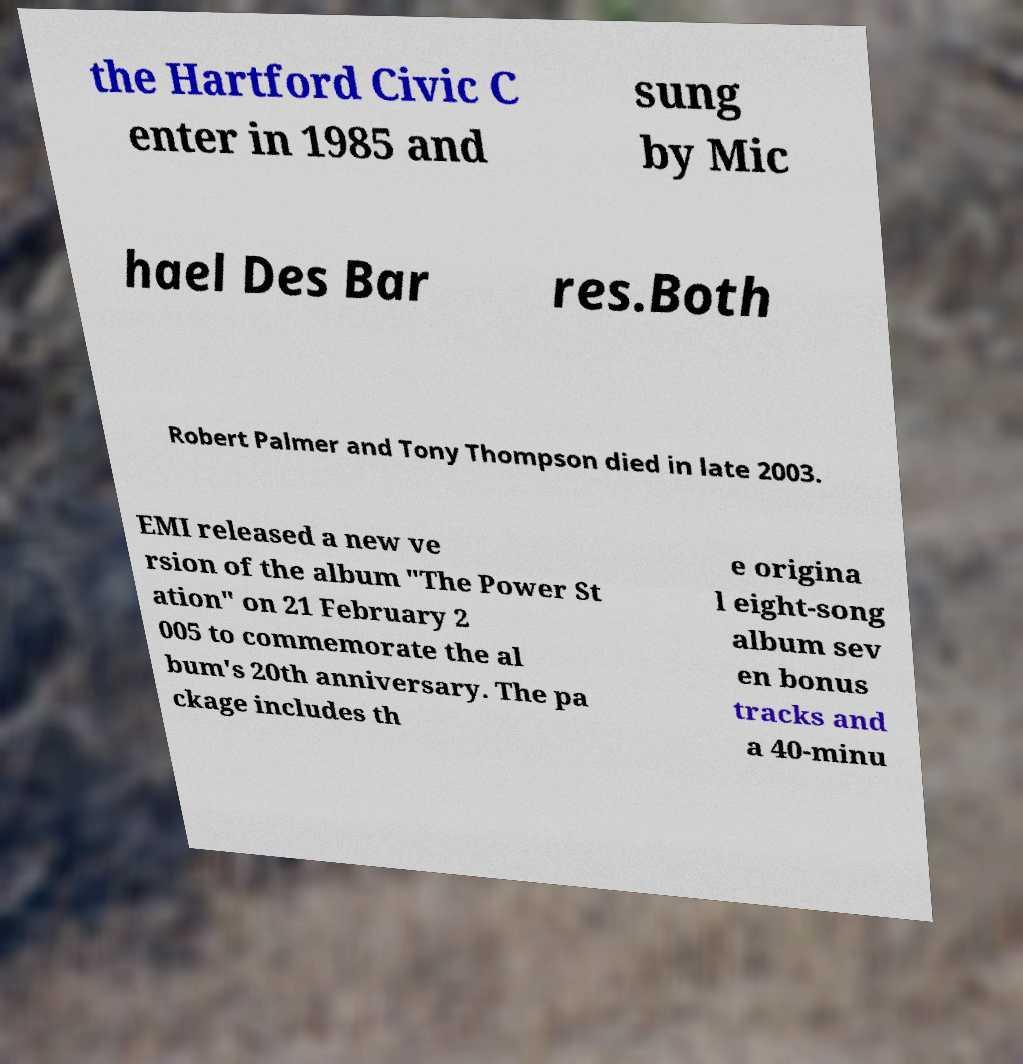Could you extract and type out the text from this image? the Hartford Civic C enter in 1985 and sung by Mic hael Des Bar res.Both Robert Palmer and Tony Thompson died in late 2003. EMI released a new ve rsion of the album "The Power St ation" on 21 February 2 005 to commemorate the al bum's 20th anniversary. The pa ckage includes th e origina l eight-song album sev en bonus tracks and a 40-minu 